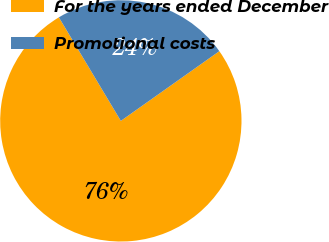Convert chart. <chart><loc_0><loc_0><loc_500><loc_500><pie_chart><fcel>For the years ended December<fcel>Promotional costs<nl><fcel>76.22%<fcel>23.78%<nl></chart> 